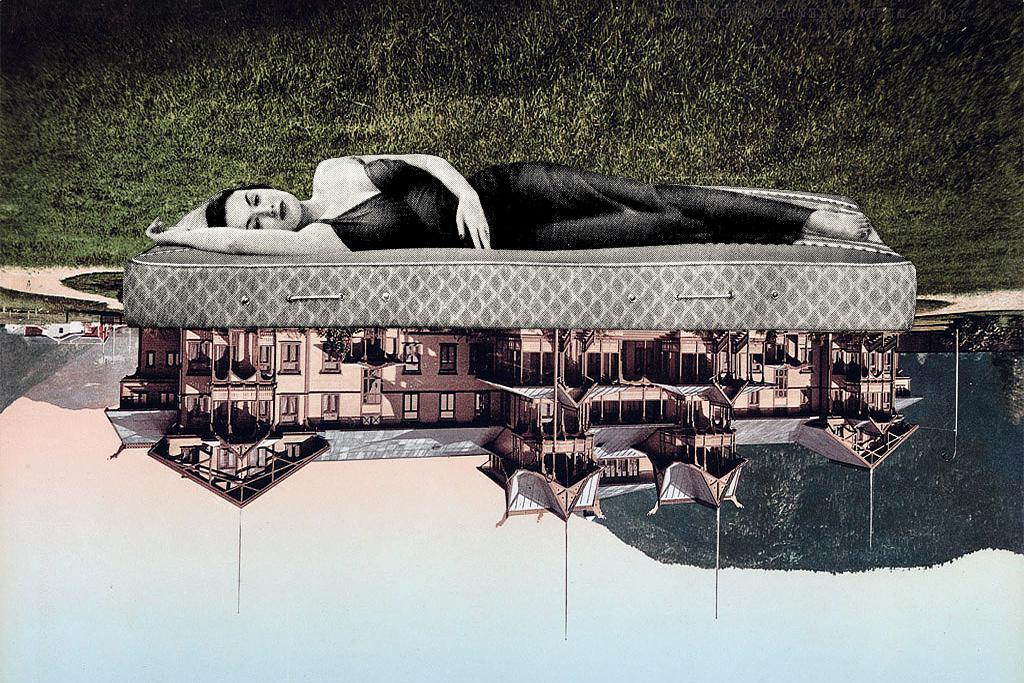What type of visual element is present in the image? The image contains a graphical representation. What natural element is visible in the image? Grass is visible in the image. What architectural feature is reflected in the water? There is a reflection of a building in water. What is the woman in the image doing? A woman is sleeping on a bed in the image. What type of volleyball court can be seen in the image? There is no volleyball court present in the image. How many boxes are stacked on the bed in the image? There are no boxes visible in the image; a woman is sleeping on the bed. 